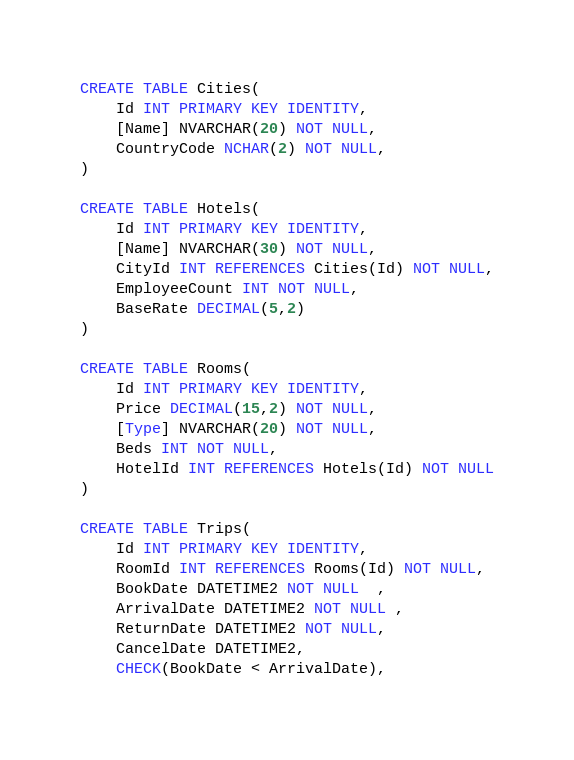<code> <loc_0><loc_0><loc_500><loc_500><_SQL_>CREATE TABLE Cities(
	Id INT PRIMARY KEY IDENTITY,
	[Name] NVARCHAR(20) NOT NULL,
	CountryCode NCHAR(2) NOT NULL,
)

CREATE TABLE Hotels(
	Id INT PRIMARY KEY IDENTITY,
	[Name] NVARCHAR(30) NOT NULL,
	CityId INT REFERENCES Cities(Id) NOT NULL,
	EmployeeCount INT NOT NULL,
	BaseRate DECIMAL(5,2)
)

CREATE TABLE Rooms(
	Id INT PRIMARY KEY IDENTITY,
	Price DECIMAL(15,2) NOT NULL,
	[Type] NVARCHAR(20) NOT NULL,
	Beds INT NOT NULL,
	HotelId INT REFERENCES Hotels(Id) NOT NULL
)

CREATE TABLE Trips(
	Id INT PRIMARY KEY IDENTITY,
	RoomId INT REFERENCES Rooms(Id) NOT NULL,
	BookDate DATETIME2 NOT NULL  ,
	ArrivalDate DATETIME2 NOT NULL ,
	ReturnDate DATETIME2 NOT NULL,
	CancelDate DATETIME2,
	CHECK(BookDate < ArrivalDate),</code> 